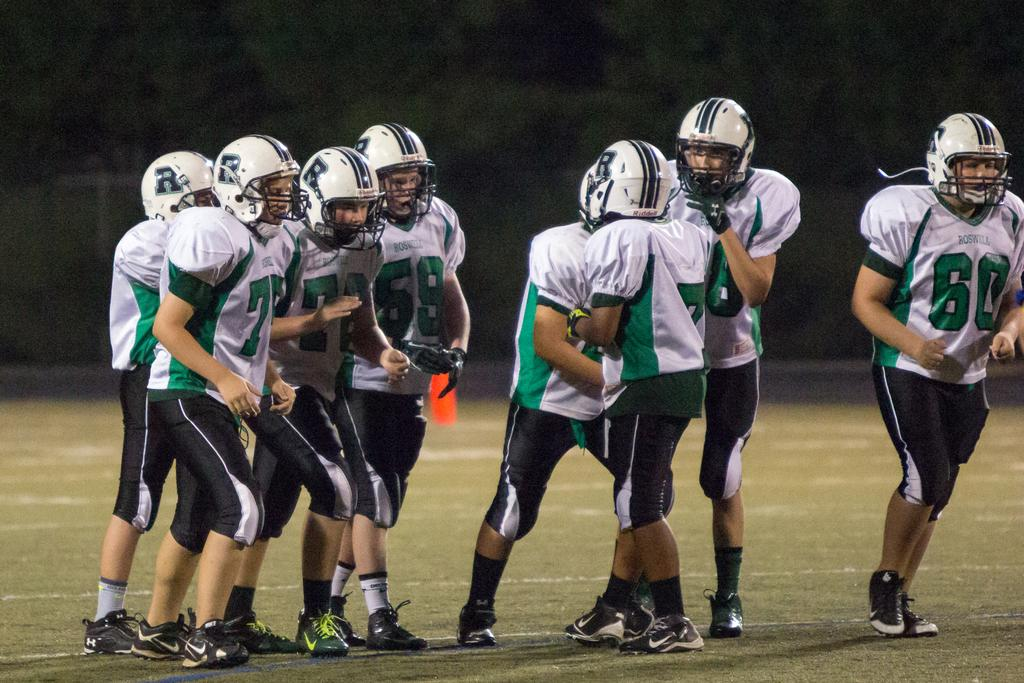What are the people in the image doing? The people in the image are standing on the ground. What are the people wearing in the image? The people are wearing jerseys and helmets. What type of surface is under the people's feet in the image? There is grass on the ground. What is the color of the background in the image? The background of the image is dark. Can you see a goat in the image? No, there is no goat present in the image. What type of knee injury can be seen on one of the people in the image? There is no knee injury visible in the image; the people are wearing helmets and jerseys, but no injuries are mentioned or depicted. 